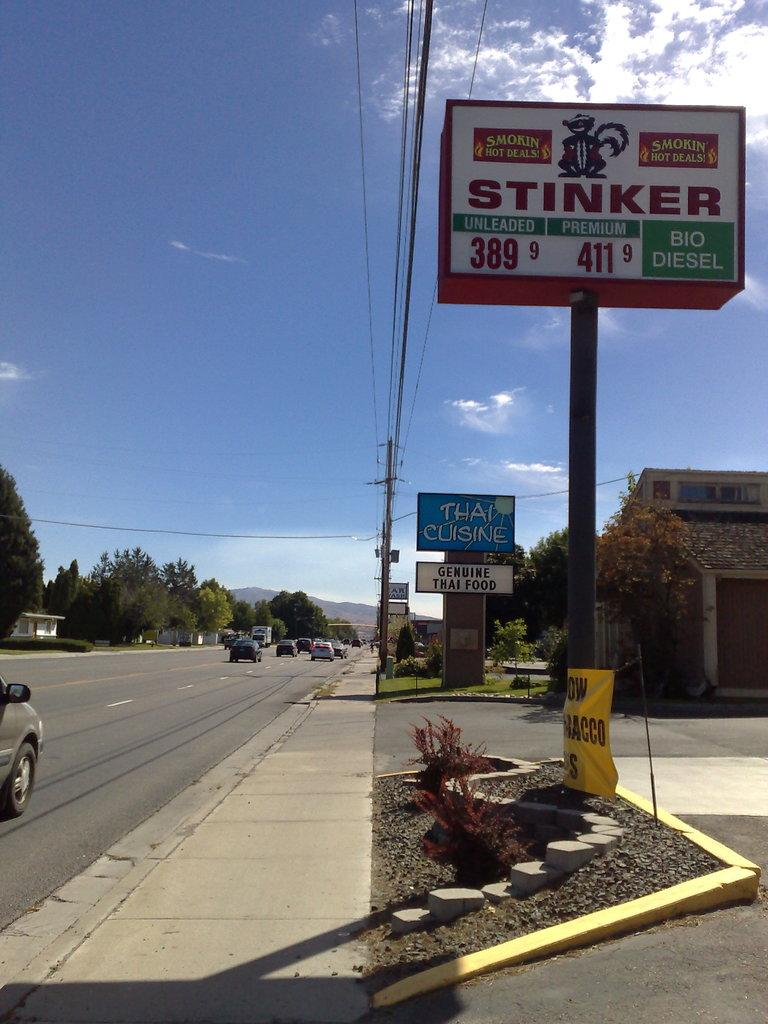What is the main feature of the image? There is a road in the image. What is happening on the road? Cars are riding on the road. What is located beside the road? There is a building beside the road. What type of vegetation can be seen in the image? Trees are present in the image. What else can be seen in the image besides the road and cars? There are poles with boards in the image. How many clovers can be seen growing on the road in the image? There are no clovers visible in the image; it features a road with cars, a building, trees, and poles with boards. What type of account is being discussed by the people in the image? There are no people present in the image, and therefore no discussion about an account can be observed. 